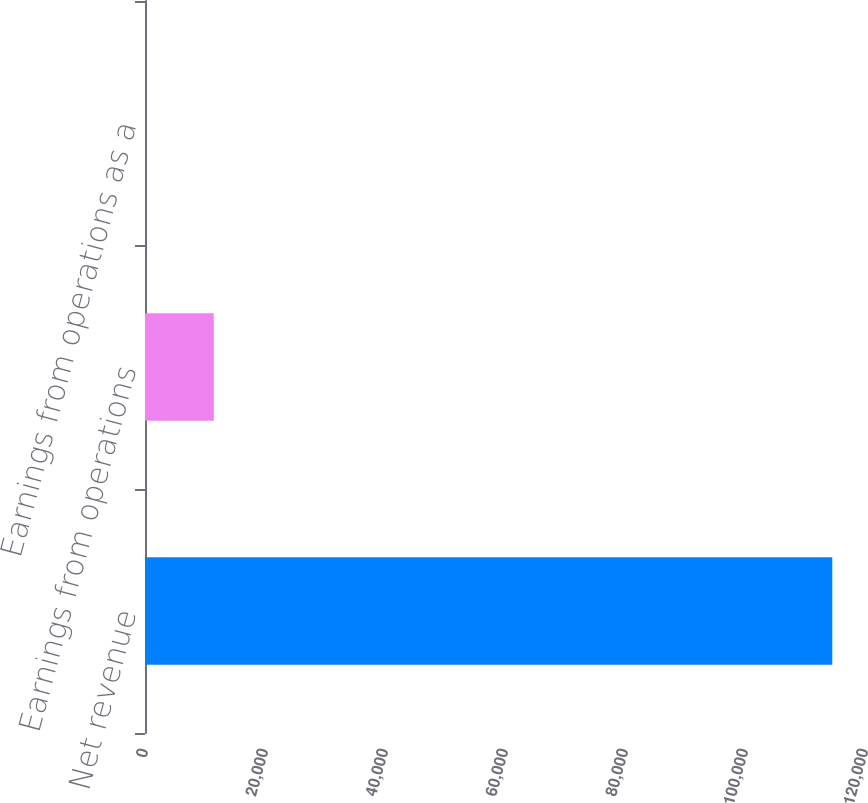Convert chart to OTSL. <chart><loc_0><loc_0><loc_500><loc_500><bar_chart><fcel>Net revenue<fcel>Earnings from operations<fcel>Earnings from operations as a<nl><fcel>114552<fcel>11463.1<fcel>8.8<nl></chart> 